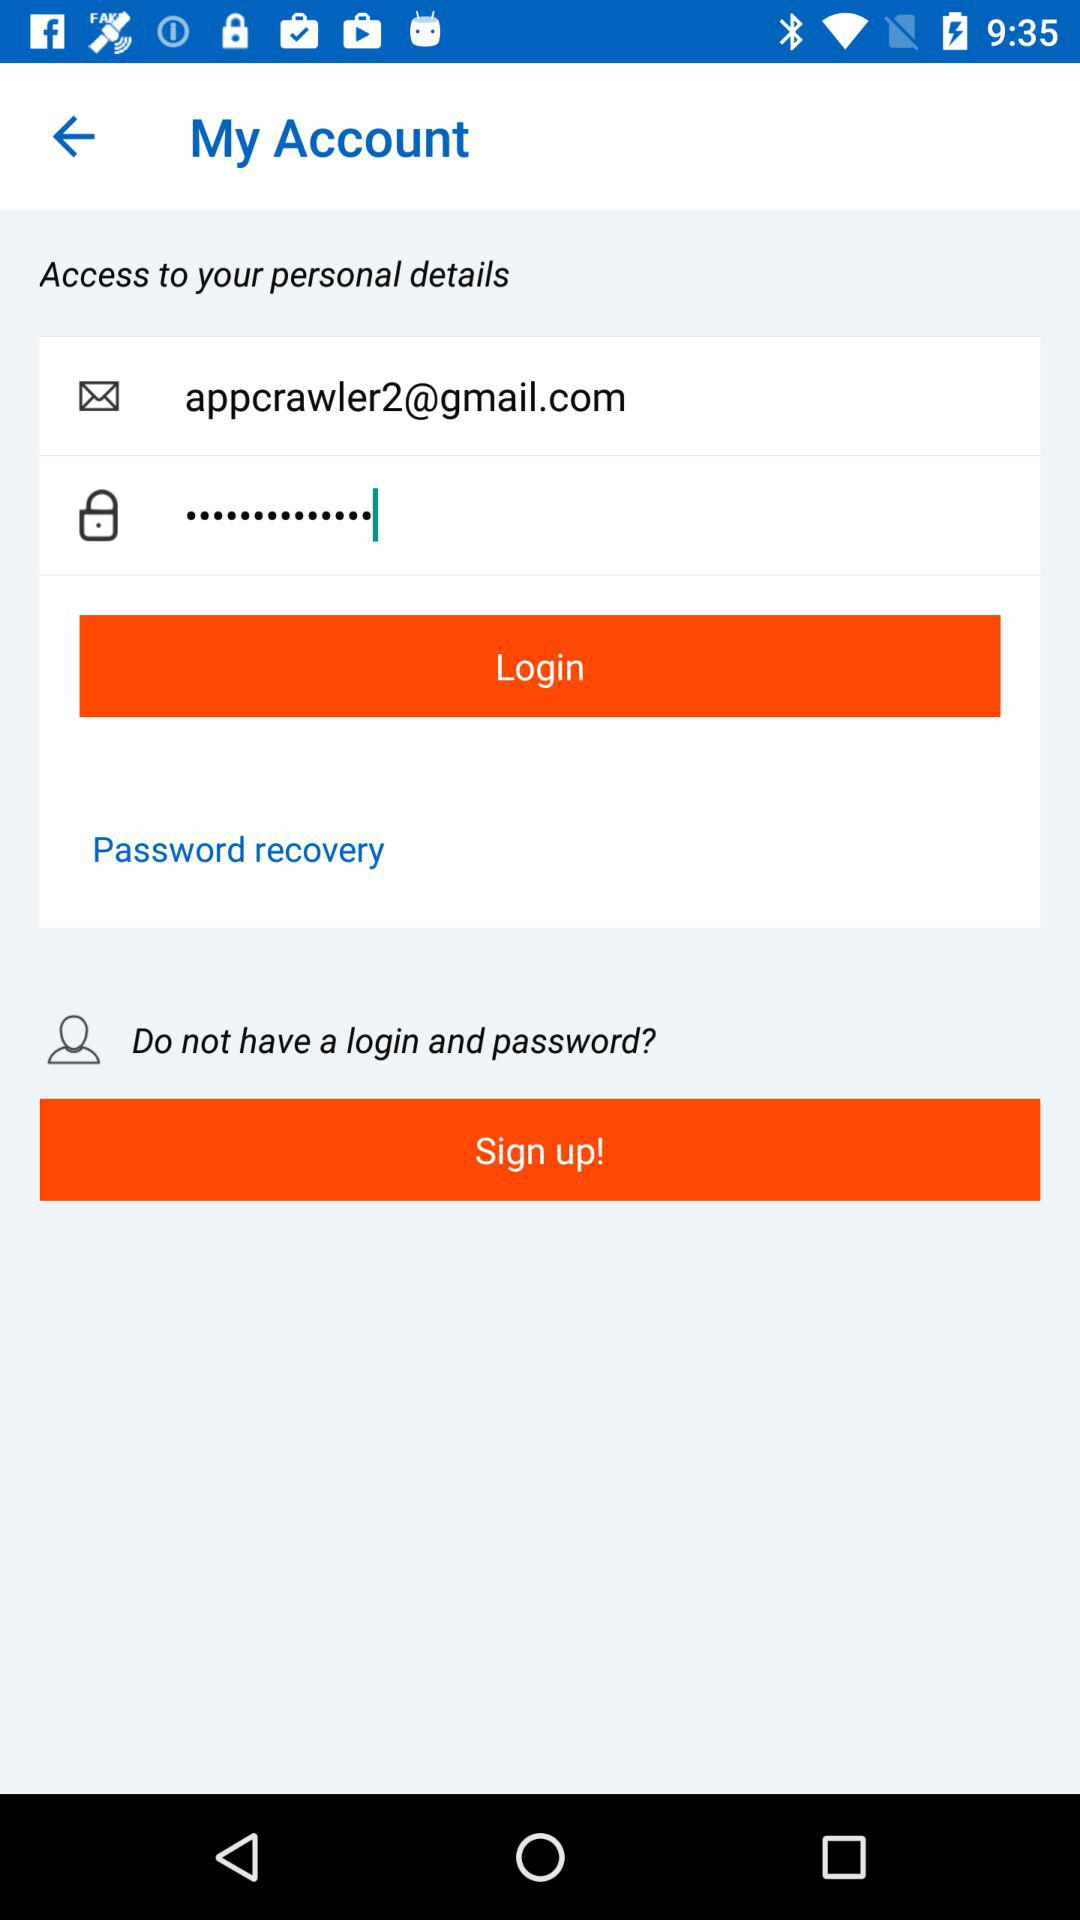What is the email address? The email address is appcrawler2@gmail.com. 